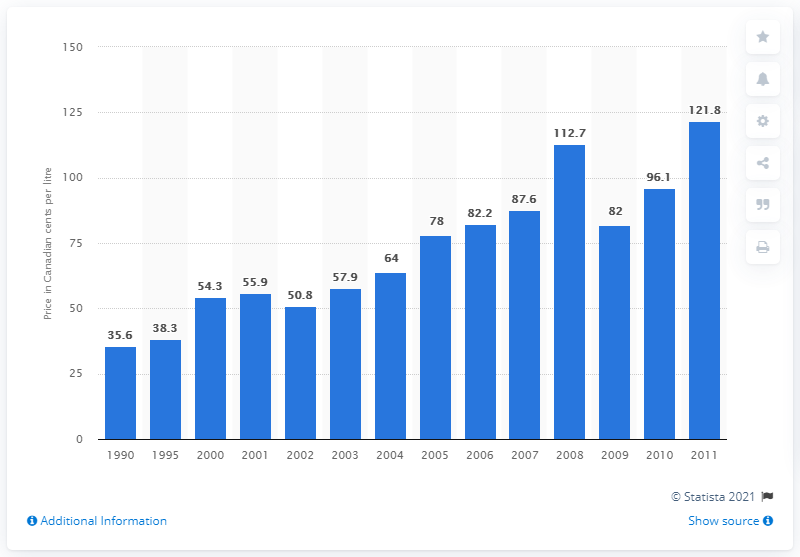Mention a couple of crucial points in this snapshot. In 2000, the average price per litre of home heating oil in Toronto was 54.3 cents. 